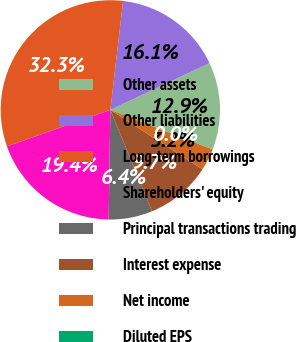Convert chart. <chart><loc_0><loc_0><loc_500><loc_500><pie_chart><fcel>Other assets<fcel>Other liabilities<fcel>Long-term borrowings<fcel>Shareholders' equity<fcel>Principal transactions trading<fcel>Interest expense<fcel>Net income<fcel>Diluted EPS<nl><fcel>12.9%<fcel>16.13%<fcel>32.26%<fcel>19.35%<fcel>6.45%<fcel>9.68%<fcel>3.23%<fcel>0.0%<nl></chart> 